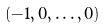Convert formula to latex. <formula><loc_0><loc_0><loc_500><loc_500>( - 1 , 0 , \dots , 0 )</formula> 